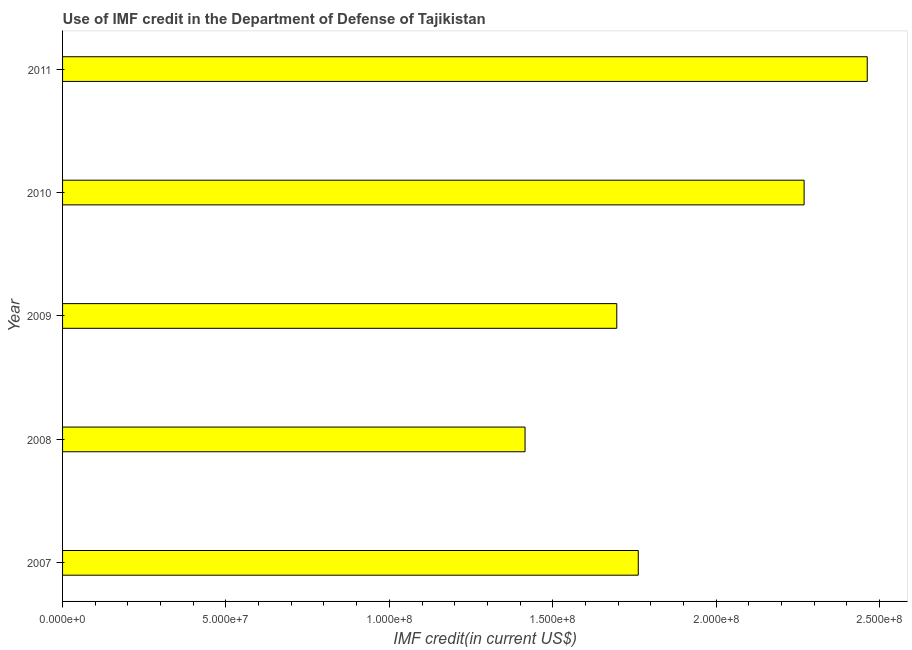What is the title of the graph?
Offer a terse response. Use of IMF credit in the Department of Defense of Tajikistan. What is the label or title of the X-axis?
Keep it short and to the point. IMF credit(in current US$). What is the use of imf credit in dod in 2007?
Keep it short and to the point. 1.76e+08. Across all years, what is the maximum use of imf credit in dod?
Give a very brief answer. 2.46e+08. Across all years, what is the minimum use of imf credit in dod?
Your answer should be compact. 1.42e+08. In which year was the use of imf credit in dod minimum?
Make the answer very short. 2008. What is the sum of the use of imf credit in dod?
Ensure brevity in your answer.  9.60e+08. What is the difference between the use of imf credit in dod in 2007 and 2009?
Make the answer very short. 6.57e+06. What is the average use of imf credit in dod per year?
Your answer should be very brief. 1.92e+08. What is the median use of imf credit in dod?
Provide a short and direct response. 1.76e+08. What is the ratio of the use of imf credit in dod in 2009 to that in 2011?
Your answer should be compact. 0.69. What is the difference between the highest and the second highest use of imf credit in dod?
Offer a terse response. 1.93e+07. Is the sum of the use of imf credit in dod in 2007 and 2010 greater than the maximum use of imf credit in dod across all years?
Your response must be concise. Yes. What is the difference between the highest and the lowest use of imf credit in dod?
Your response must be concise. 1.05e+08. How many bars are there?
Offer a terse response. 5. Are all the bars in the graph horizontal?
Your answer should be compact. Yes. What is the difference between two consecutive major ticks on the X-axis?
Give a very brief answer. 5.00e+07. What is the IMF credit(in current US$) in 2007?
Offer a very short reply. 1.76e+08. What is the IMF credit(in current US$) in 2008?
Give a very brief answer. 1.42e+08. What is the IMF credit(in current US$) in 2009?
Your response must be concise. 1.70e+08. What is the IMF credit(in current US$) in 2010?
Your answer should be very brief. 2.27e+08. What is the IMF credit(in current US$) in 2011?
Your answer should be very brief. 2.46e+08. What is the difference between the IMF credit(in current US$) in 2007 and 2008?
Offer a very short reply. 3.46e+07. What is the difference between the IMF credit(in current US$) in 2007 and 2009?
Give a very brief answer. 6.57e+06. What is the difference between the IMF credit(in current US$) in 2007 and 2010?
Ensure brevity in your answer.  -5.08e+07. What is the difference between the IMF credit(in current US$) in 2007 and 2011?
Offer a very short reply. -7.01e+07. What is the difference between the IMF credit(in current US$) in 2008 and 2009?
Make the answer very short. -2.81e+07. What is the difference between the IMF credit(in current US$) in 2008 and 2010?
Offer a terse response. -8.54e+07. What is the difference between the IMF credit(in current US$) in 2008 and 2011?
Keep it short and to the point. -1.05e+08. What is the difference between the IMF credit(in current US$) in 2009 and 2010?
Offer a terse response. -5.73e+07. What is the difference between the IMF credit(in current US$) in 2009 and 2011?
Your answer should be compact. -7.66e+07. What is the difference between the IMF credit(in current US$) in 2010 and 2011?
Offer a very short reply. -1.93e+07. What is the ratio of the IMF credit(in current US$) in 2007 to that in 2008?
Offer a terse response. 1.25. What is the ratio of the IMF credit(in current US$) in 2007 to that in 2009?
Your response must be concise. 1.04. What is the ratio of the IMF credit(in current US$) in 2007 to that in 2010?
Provide a short and direct response. 0.78. What is the ratio of the IMF credit(in current US$) in 2007 to that in 2011?
Provide a succinct answer. 0.71. What is the ratio of the IMF credit(in current US$) in 2008 to that in 2009?
Keep it short and to the point. 0.83. What is the ratio of the IMF credit(in current US$) in 2008 to that in 2010?
Offer a very short reply. 0.62. What is the ratio of the IMF credit(in current US$) in 2008 to that in 2011?
Give a very brief answer. 0.57. What is the ratio of the IMF credit(in current US$) in 2009 to that in 2010?
Your answer should be compact. 0.75. What is the ratio of the IMF credit(in current US$) in 2009 to that in 2011?
Your answer should be very brief. 0.69. What is the ratio of the IMF credit(in current US$) in 2010 to that in 2011?
Offer a terse response. 0.92. 